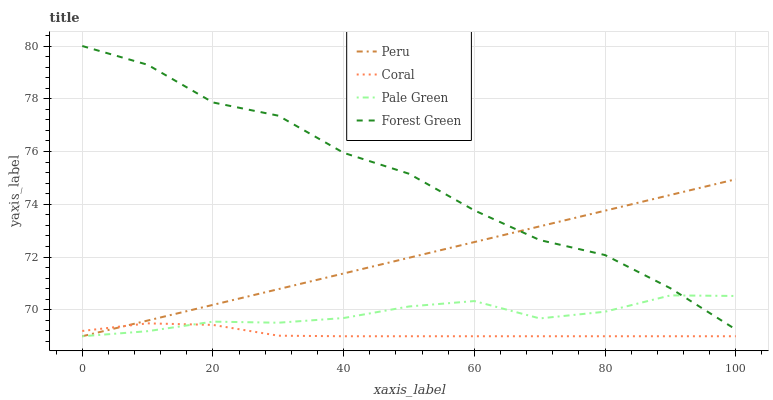Does Coral have the minimum area under the curve?
Answer yes or no. Yes. Does Forest Green have the maximum area under the curve?
Answer yes or no. Yes. Does Pale Green have the minimum area under the curve?
Answer yes or no. No. Does Pale Green have the maximum area under the curve?
Answer yes or no. No. Is Peru the smoothest?
Answer yes or no. Yes. Is Forest Green the roughest?
Answer yes or no. Yes. Is Pale Green the smoothest?
Answer yes or no. No. Is Pale Green the roughest?
Answer yes or no. No. Does Coral have the lowest value?
Answer yes or no. Yes. Does Forest Green have the lowest value?
Answer yes or no. No. Does Forest Green have the highest value?
Answer yes or no. Yes. Does Pale Green have the highest value?
Answer yes or no. No. Is Coral less than Forest Green?
Answer yes or no. Yes. Is Forest Green greater than Coral?
Answer yes or no. Yes. Does Pale Green intersect Coral?
Answer yes or no. Yes. Is Pale Green less than Coral?
Answer yes or no. No. Is Pale Green greater than Coral?
Answer yes or no. No. Does Coral intersect Forest Green?
Answer yes or no. No. 